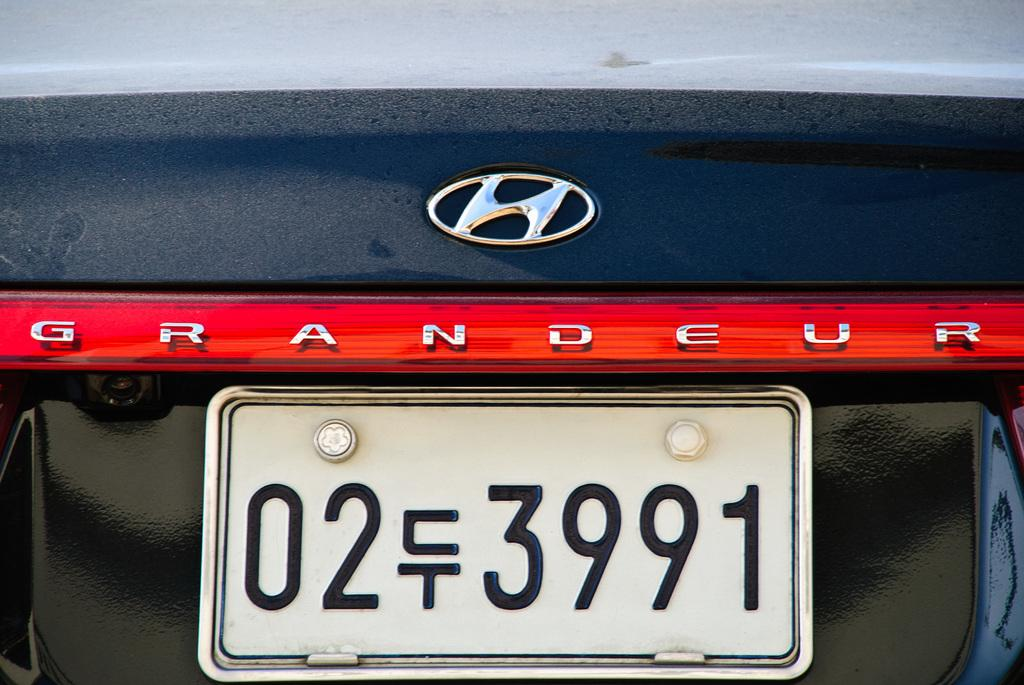<image>
Present a compact description of the photo's key features. A white tag with 02 399l on a Grandeur. 